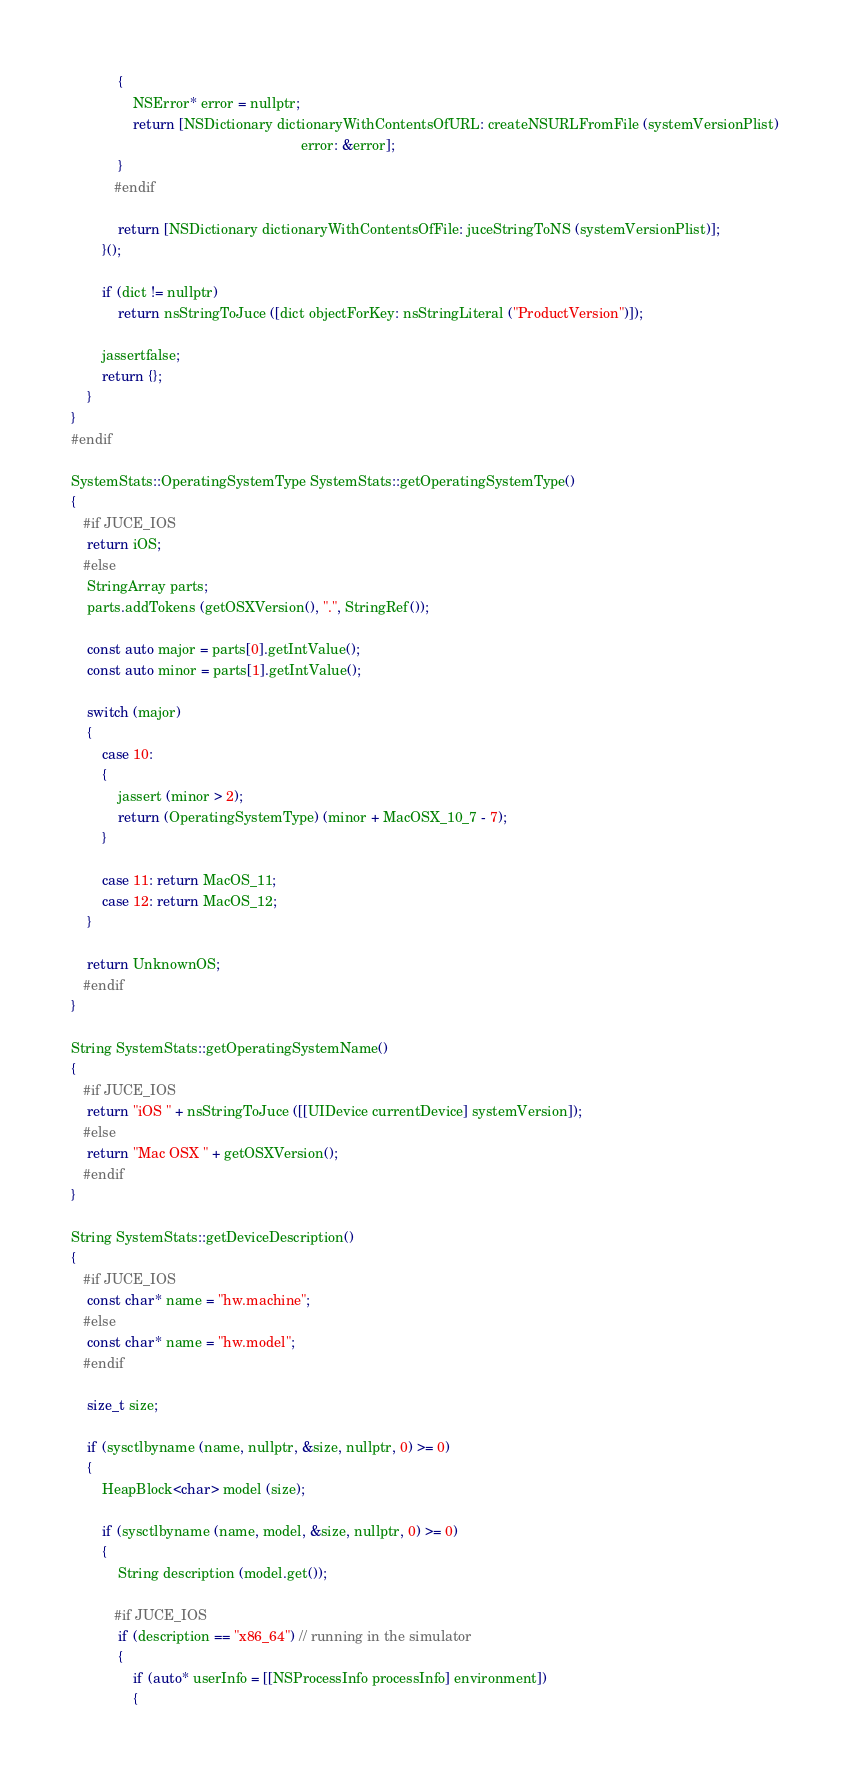<code> <loc_0><loc_0><loc_500><loc_500><_ObjectiveC_>            {
                NSError* error = nullptr;
                return [NSDictionary dictionaryWithContentsOfURL: createNSURLFromFile (systemVersionPlist)
                                                           error: &error];
            }
           #endif

            return [NSDictionary dictionaryWithContentsOfFile: juceStringToNS (systemVersionPlist)];
        }();

        if (dict != nullptr)
            return nsStringToJuce ([dict objectForKey: nsStringLiteral ("ProductVersion")]);

        jassertfalse;
        return {};
    }
}
#endif

SystemStats::OperatingSystemType SystemStats::getOperatingSystemType()
{
   #if JUCE_IOS
    return iOS;
   #else
    StringArray parts;
    parts.addTokens (getOSXVersion(), ".", StringRef());

    const auto major = parts[0].getIntValue();
    const auto minor = parts[1].getIntValue();

    switch (major)
    {
        case 10:
        {
            jassert (minor > 2);
            return (OperatingSystemType) (minor + MacOSX_10_7 - 7);
        }

        case 11: return MacOS_11;
        case 12: return MacOS_12;
    }

    return UnknownOS;
   #endif
}

String SystemStats::getOperatingSystemName()
{
   #if JUCE_IOS
    return "iOS " + nsStringToJuce ([[UIDevice currentDevice] systemVersion]);
   #else
    return "Mac OSX " + getOSXVersion();
   #endif
}

String SystemStats::getDeviceDescription()
{
   #if JUCE_IOS
    const char* name = "hw.machine";
   #else
    const char* name = "hw.model";
   #endif

    size_t size;

    if (sysctlbyname (name, nullptr, &size, nullptr, 0) >= 0)
    {
        HeapBlock<char> model (size);

        if (sysctlbyname (name, model, &size, nullptr, 0) >= 0)
        {
            String description (model.get());

           #if JUCE_IOS
            if (description == "x86_64") // running in the simulator
            {
                if (auto* userInfo = [[NSProcessInfo processInfo] environment])
                {</code> 